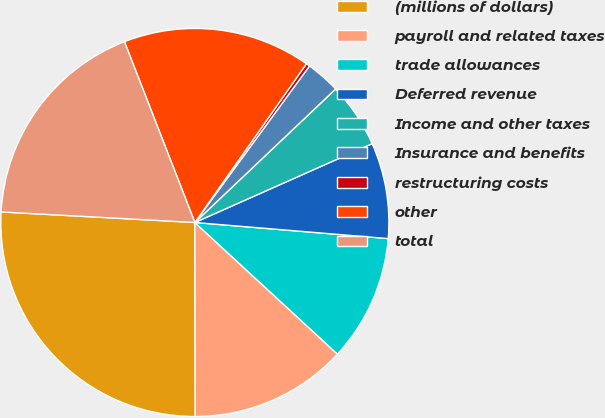<chart> <loc_0><loc_0><loc_500><loc_500><pie_chart><fcel>(millions of dollars)<fcel>payroll and related taxes<fcel>trade allowances<fcel>Deferred revenue<fcel>Income and other taxes<fcel>Insurance and benefits<fcel>restructuring costs<fcel>other<fcel>total<nl><fcel>25.9%<fcel>13.1%<fcel>10.54%<fcel>7.98%<fcel>5.42%<fcel>2.86%<fcel>0.31%<fcel>15.66%<fcel>18.22%<nl></chart> 